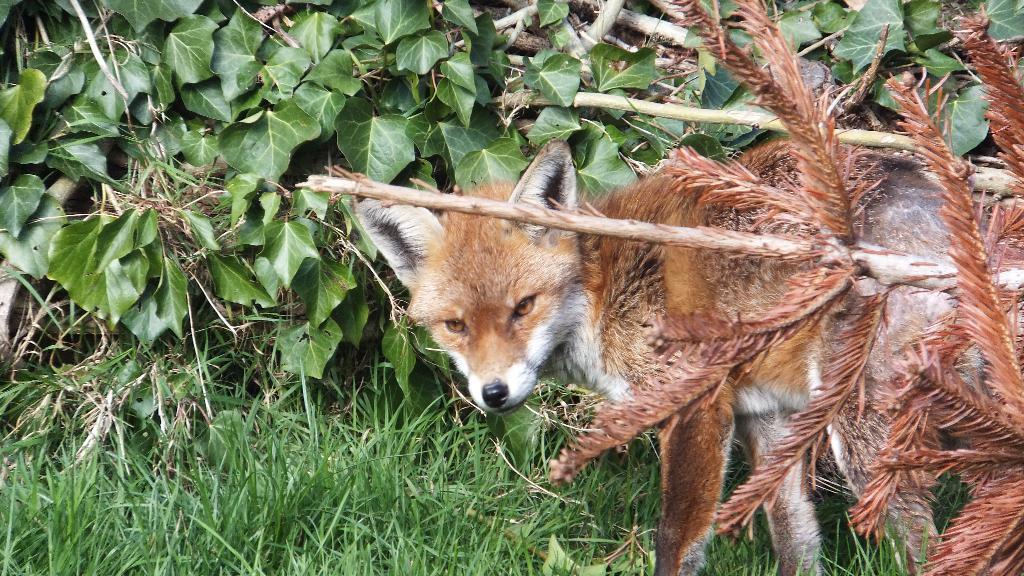How would you summarize this image in a sentence or two? In this picture there is a fox which is standing near to the plants and grass. On the right i can see bamboos. On the left i can see many leaves. 